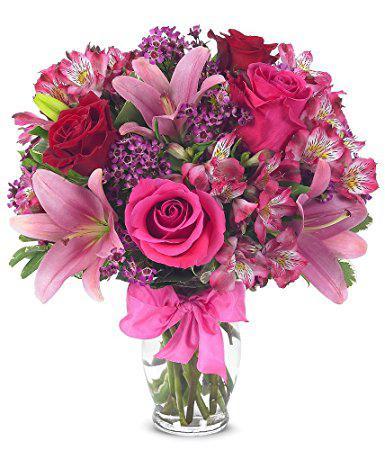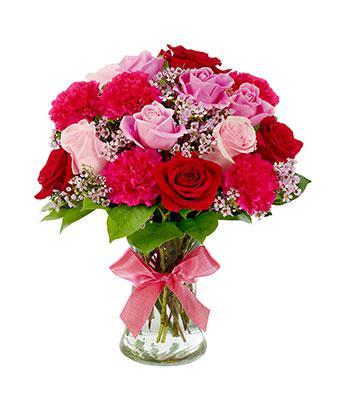The first image is the image on the left, the second image is the image on the right. For the images shown, is this caption "There is a bow around the vase in the image on the right." true? Answer yes or no. Yes. 